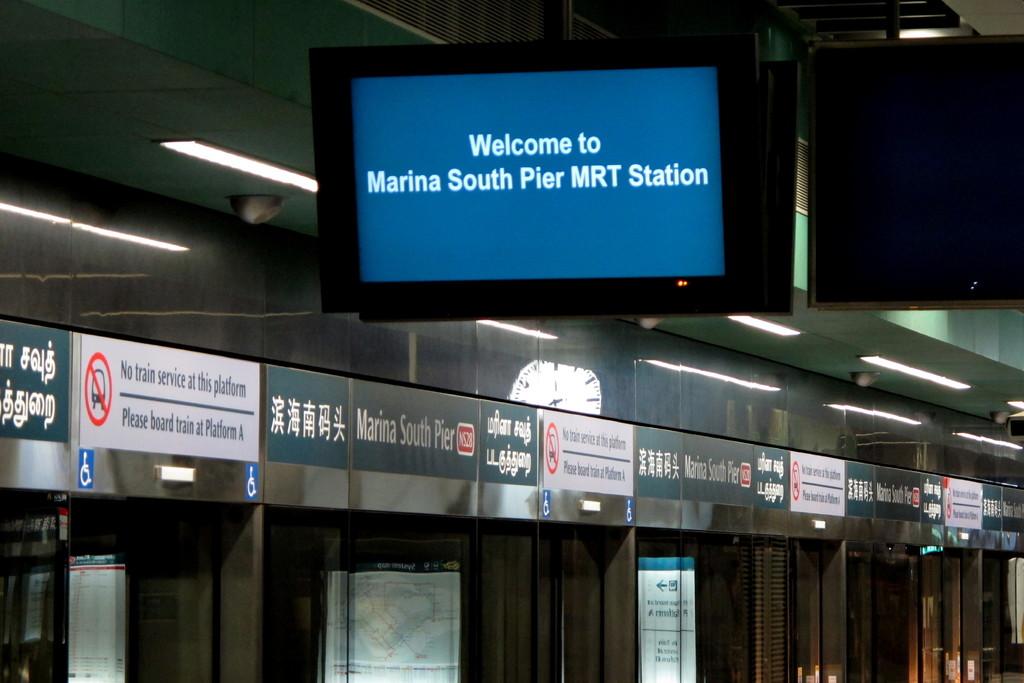What is the name of the station?
Give a very brief answer. Marina south pier mrt station. What is the instruction written in the board?
Offer a very short reply. Welcome to marina south pier mrt station. 